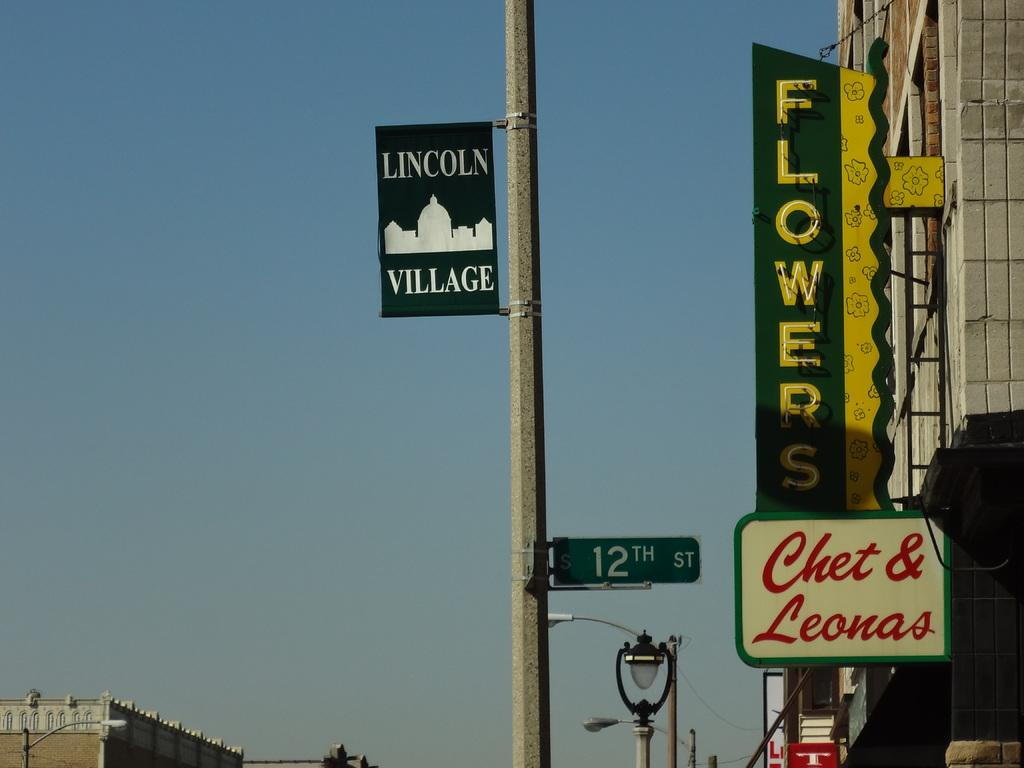<image>
Present a compact description of the photo's key features. a sign that says Lincoln Village on it 